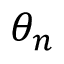Convert formula to latex. <formula><loc_0><loc_0><loc_500><loc_500>\theta _ { n }</formula> 